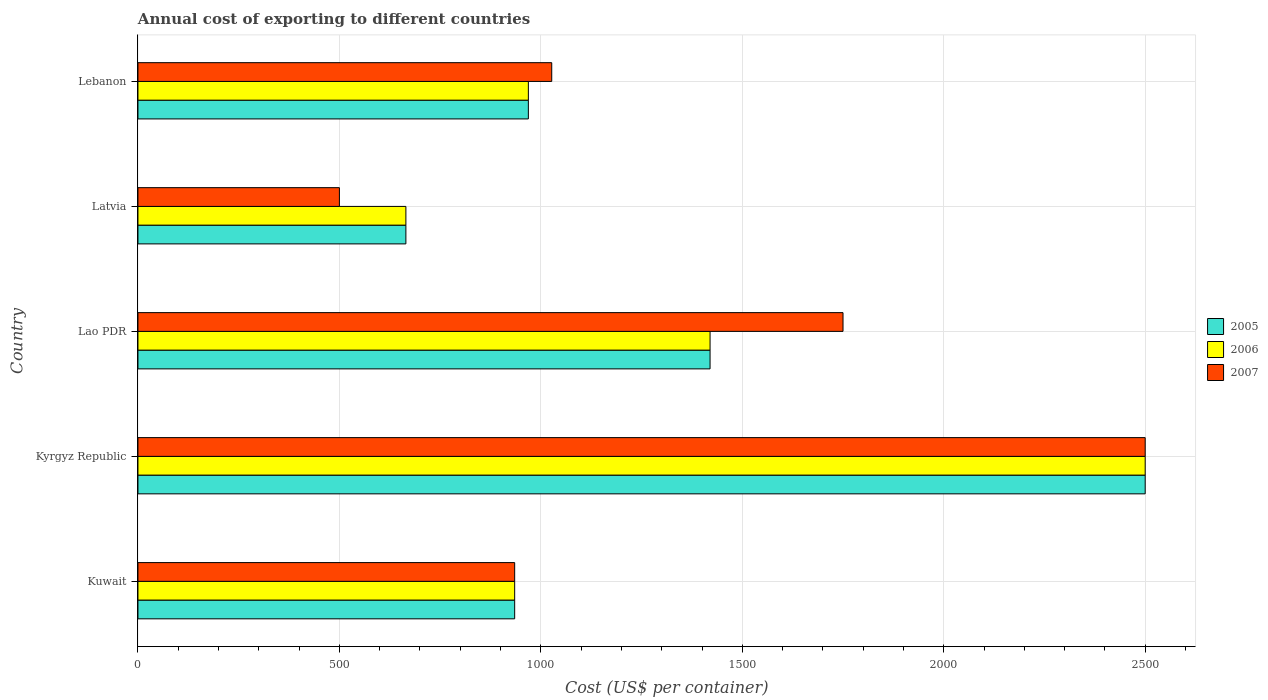How many different coloured bars are there?
Give a very brief answer. 3. How many groups of bars are there?
Your answer should be compact. 5. How many bars are there on the 3rd tick from the bottom?
Your answer should be compact. 3. What is the label of the 2nd group of bars from the top?
Your answer should be very brief. Latvia. What is the total annual cost of exporting in 2007 in Kyrgyz Republic?
Keep it short and to the point. 2500. Across all countries, what is the maximum total annual cost of exporting in 2007?
Ensure brevity in your answer.  2500. In which country was the total annual cost of exporting in 2005 maximum?
Ensure brevity in your answer.  Kyrgyz Republic. In which country was the total annual cost of exporting in 2007 minimum?
Offer a terse response. Latvia. What is the total total annual cost of exporting in 2006 in the graph?
Offer a very short reply. 6489. What is the difference between the total annual cost of exporting in 2005 in Latvia and that in Lebanon?
Offer a very short reply. -304. What is the difference between the total annual cost of exporting in 2005 in Lao PDR and the total annual cost of exporting in 2006 in Kyrgyz Republic?
Provide a succinct answer. -1080. What is the average total annual cost of exporting in 2007 per country?
Provide a short and direct response. 1342.4. What is the difference between the total annual cost of exporting in 2007 and total annual cost of exporting in 2006 in Lao PDR?
Keep it short and to the point. 330. In how many countries, is the total annual cost of exporting in 2006 greater than 400 US$?
Your response must be concise. 5. What is the ratio of the total annual cost of exporting in 2006 in Kuwait to that in Kyrgyz Republic?
Offer a very short reply. 0.37. Is the total annual cost of exporting in 2005 in Kuwait less than that in Lebanon?
Give a very brief answer. Yes. What is the difference between the highest and the second highest total annual cost of exporting in 2007?
Make the answer very short. 750. What is the difference between the highest and the lowest total annual cost of exporting in 2006?
Provide a short and direct response. 1835. Is the sum of the total annual cost of exporting in 2006 in Lao PDR and Latvia greater than the maximum total annual cost of exporting in 2007 across all countries?
Offer a terse response. No. What does the 2nd bar from the bottom in Kyrgyz Republic represents?
Your answer should be compact. 2006. Are the values on the major ticks of X-axis written in scientific E-notation?
Your answer should be compact. No. Does the graph contain any zero values?
Ensure brevity in your answer.  No. How many legend labels are there?
Your answer should be compact. 3. What is the title of the graph?
Ensure brevity in your answer.  Annual cost of exporting to different countries. What is the label or title of the X-axis?
Provide a succinct answer. Cost (US$ per container). What is the label or title of the Y-axis?
Give a very brief answer. Country. What is the Cost (US$ per container) in 2005 in Kuwait?
Provide a succinct answer. 935. What is the Cost (US$ per container) of 2006 in Kuwait?
Ensure brevity in your answer.  935. What is the Cost (US$ per container) in 2007 in Kuwait?
Offer a terse response. 935. What is the Cost (US$ per container) in 2005 in Kyrgyz Republic?
Provide a short and direct response. 2500. What is the Cost (US$ per container) in 2006 in Kyrgyz Republic?
Make the answer very short. 2500. What is the Cost (US$ per container) of 2007 in Kyrgyz Republic?
Keep it short and to the point. 2500. What is the Cost (US$ per container) in 2005 in Lao PDR?
Provide a short and direct response. 1420. What is the Cost (US$ per container) of 2006 in Lao PDR?
Your response must be concise. 1420. What is the Cost (US$ per container) in 2007 in Lao PDR?
Your response must be concise. 1750. What is the Cost (US$ per container) in 2005 in Latvia?
Ensure brevity in your answer.  665. What is the Cost (US$ per container) of 2006 in Latvia?
Give a very brief answer. 665. What is the Cost (US$ per container) in 2005 in Lebanon?
Make the answer very short. 969. What is the Cost (US$ per container) in 2006 in Lebanon?
Ensure brevity in your answer.  969. What is the Cost (US$ per container) in 2007 in Lebanon?
Provide a short and direct response. 1027. Across all countries, what is the maximum Cost (US$ per container) of 2005?
Your answer should be compact. 2500. Across all countries, what is the maximum Cost (US$ per container) of 2006?
Ensure brevity in your answer.  2500. Across all countries, what is the maximum Cost (US$ per container) in 2007?
Keep it short and to the point. 2500. Across all countries, what is the minimum Cost (US$ per container) in 2005?
Give a very brief answer. 665. Across all countries, what is the minimum Cost (US$ per container) in 2006?
Give a very brief answer. 665. What is the total Cost (US$ per container) in 2005 in the graph?
Ensure brevity in your answer.  6489. What is the total Cost (US$ per container) in 2006 in the graph?
Keep it short and to the point. 6489. What is the total Cost (US$ per container) in 2007 in the graph?
Offer a very short reply. 6712. What is the difference between the Cost (US$ per container) of 2005 in Kuwait and that in Kyrgyz Republic?
Give a very brief answer. -1565. What is the difference between the Cost (US$ per container) of 2006 in Kuwait and that in Kyrgyz Republic?
Offer a terse response. -1565. What is the difference between the Cost (US$ per container) of 2007 in Kuwait and that in Kyrgyz Republic?
Offer a terse response. -1565. What is the difference between the Cost (US$ per container) in 2005 in Kuwait and that in Lao PDR?
Your answer should be very brief. -485. What is the difference between the Cost (US$ per container) of 2006 in Kuwait and that in Lao PDR?
Your answer should be very brief. -485. What is the difference between the Cost (US$ per container) of 2007 in Kuwait and that in Lao PDR?
Keep it short and to the point. -815. What is the difference between the Cost (US$ per container) of 2005 in Kuwait and that in Latvia?
Keep it short and to the point. 270. What is the difference between the Cost (US$ per container) in 2006 in Kuwait and that in Latvia?
Offer a terse response. 270. What is the difference between the Cost (US$ per container) in 2007 in Kuwait and that in Latvia?
Provide a short and direct response. 435. What is the difference between the Cost (US$ per container) in 2005 in Kuwait and that in Lebanon?
Give a very brief answer. -34. What is the difference between the Cost (US$ per container) of 2006 in Kuwait and that in Lebanon?
Ensure brevity in your answer.  -34. What is the difference between the Cost (US$ per container) of 2007 in Kuwait and that in Lebanon?
Your response must be concise. -92. What is the difference between the Cost (US$ per container) of 2005 in Kyrgyz Republic and that in Lao PDR?
Your answer should be compact. 1080. What is the difference between the Cost (US$ per container) in 2006 in Kyrgyz Republic and that in Lao PDR?
Offer a terse response. 1080. What is the difference between the Cost (US$ per container) in 2007 in Kyrgyz Republic and that in Lao PDR?
Provide a succinct answer. 750. What is the difference between the Cost (US$ per container) in 2005 in Kyrgyz Republic and that in Latvia?
Your answer should be very brief. 1835. What is the difference between the Cost (US$ per container) in 2006 in Kyrgyz Republic and that in Latvia?
Make the answer very short. 1835. What is the difference between the Cost (US$ per container) of 2007 in Kyrgyz Republic and that in Latvia?
Provide a succinct answer. 2000. What is the difference between the Cost (US$ per container) of 2005 in Kyrgyz Republic and that in Lebanon?
Your response must be concise. 1531. What is the difference between the Cost (US$ per container) of 2006 in Kyrgyz Republic and that in Lebanon?
Your answer should be very brief. 1531. What is the difference between the Cost (US$ per container) in 2007 in Kyrgyz Republic and that in Lebanon?
Provide a succinct answer. 1473. What is the difference between the Cost (US$ per container) of 2005 in Lao PDR and that in Latvia?
Provide a short and direct response. 755. What is the difference between the Cost (US$ per container) of 2006 in Lao PDR and that in Latvia?
Ensure brevity in your answer.  755. What is the difference between the Cost (US$ per container) of 2007 in Lao PDR and that in Latvia?
Your answer should be compact. 1250. What is the difference between the Cost (US$ per container) of 2005 in Lao PDR and that in Lebanon?
Make the answer very short. 451. What is the difference between the Cost (US$ per container) of 2006 in Lao PDR and that in Lebanon?
Offer a very short reply. 451. What is the difference between the Cost (US$ per container) in 2007 in Lao PDR and that in Lebanon?
Give a very brief answer. 723. What is the difference between the Cost (US$ per container) of 2005 in Latvia and that in Lebanon?
Give a very brief answer. -304. What is the difference between the Cost (US$ per container) of 2006 in Latvia and that in Lebanon?
Your response must be concise. -304. What is the difference between the Cost (US$ per container) in 2007 in Latvia and that in Lebanon?
Provide a short and direct response. -527. What is the difference between the Cost (US$ per container) in 2005 in Kuwait and the Cost (US$ per container) in 2006 in Kyrgyz Republic?
Ensure brevity in your answer.  -1565. What is the difference between the Cost (US$ per container) of 2005 in Kuwait and the Cost (US$ per container) of 2007 in Kyrgyz Republic?
Your response must be concise. -1565. What is the difference between the Cost (US$ per container) of 2006 in Kuwait and the Cost (US$ per container) of 2007 in Kyrgyz Republic?
Provide a short and direct response. -1565. What is the difference between the Cost (US$ per container) of 2005 in Kuwait and the Cost (US$ per container) of 2006 in Lao PDR?
Your answer should be very brief. -485. What is the difference between the Cost (US$ per container) of 2005 in Kuwait and the Cost (US$ per container) of 2007 in Lao PDR?
Your answer should be compact. -815. What is the difference between the Cost (US$ per container) in 2006 in Kuwait and the Cost (US$ per container) in 2007 in Lao PDR?
Ensure brevity in your answer.  -815. What is the difference between the Cost (US$ per container) in 2005 in Kuwait and the Cost (US$ per container) in 2006 in Latvia?
Ensure brevity in your answer.  270. What is the difference between the Cost (US$ per container) in 2005 in Kuwait and the Cost (US$ per container) in 2007 in Latvia?
Ensure brevity in your answer.  435. What is the difference between the Cost (US$ per container) of 2006 in Kuwait and the Cost (US$ per container) of 2007 in Latvia?
Your answer should be compact. 435. What is the difference between the Cost (US$ per container) of 2005 in Kuwait and the Cost (US$ per container) of 2006 in Lebanon?
Keep it short and to the point. -34. What is the difference between the Cost (US$ per container) of 2005 in Kuwait and the Cost (US$ per container) of 2007 in Lebanon?
Offer a terse response. -92. What is the difference between the Cost (US$ per container) of 2006 in Kuwait and the Cost (US$ per container) of 2007 in Lebanon?
Provide a short and direct response. -92. What is the difference between the Cost (US$ per container) of 2005 in Kyrgyz Republic and the Cost (US$ per container) of 2006 in Lao PDR?
Provide a succinct answer. 1080. What is the difference between the Cost (US$ per container) in 2005 in Kyrgyz Republic and the Cost (US$ per container) in 2007 in Lao PDR?
Keep it short and to the point. 750. What is the difference between the Cost (US$ per container) of 2006 in Kyrgyz Republic and the Cost (US$ per container) of 2007 in Lao PDR?
Ensure brevity in your answer.  750. What is the difference between the Cost (US$ per container) of 2005 in Kyrgyz Republic and the Cost (US$ per container) of 2006 in Latvia?
Your response must be concise. 1835. What is the difference between the Cost (US$ per container) in 2006 in Kyrgyz Republic and the Cost (US$ per container) in 2007 in Latvia?
Ensure brevity in your answer.  2000. What is the difference between the Cost (US$ per container) in 2005 in Kyrgyz Republic and the Cost (US$ per container) in 2006 in Lebanon?
Your response must be concise. 1531. What is the difference between the Cost (US$ per container) in 2005 in Kyrgyz Republic and the Cost (US$ per container) in 2007 in Lebanon?
Offer a terse response. 1473. What is the difference between the Cost (US$ per container) in 2006 in Kyrgyz Republic and the Cost (US$ per container) in 2007 in Lebanon?
Ensure brevity in your answer.  1473. What is the difference between the Cost (US$ per container) in 2005 in Lao PDR and the Cost (US$ per container) in 2006 in Latvia?
Provide a short and direct response. 755. What is the difference between the Cost (US$ per container) in 2005 in Lao PDR and the Cost (US$ per container) in 2007 in Latvia?
Your answer should be compact. 920. What is the difference between the Cost (US$ per container) of 2006 in Lao PDR and the Cost (US$ per container) of 2007 in Latvia?
Provide a succinct answer. 920. What is the difference between the Cost (US$ per container) in 2005 in Lao PDR and the Cost (US$ per container) in 2006 in Lebanon?
Provide a short and direct response. 451. What is the difference between the Cost (US$ per container) in 2005 in Lao PDR and the Cost (US$ per container) in 2007 in Lebanon?
Your answer should be very brief. 393. What is the difference between the Cost (US$ per container) in 2006 in Lao PDR and the Cost (US$ per container) in 2007 in Lebanon?
Make the answer very short. 393. What is the difference between the Cost (US$ per container) in 2005 in Latvia and the Cost (US$ per container) in 2006 in Lebanon?
Your answer should be very brief. -304. What is the difference between the Cost (US$ per container) in 2005 in Latvia and the Cost (US$ per container) in 2007 in Lebanon?
Keep it short and to the point. -362. What is the difference between the Cost (US$ per container) in 2006 in Latvia and the Cost (US$ per container) in 2007 in Lebanon?
Your answer should be very brief. -362. What is the average Cost (US$ per container) of 2005 per country?
Make the answer very short. 1297.8. What is the average Cost (US$ per container) in 2006 per country?
Your answer should be compact. 1297.8. What is the average Cost (US$ per container) of 2007 per country?
Offer a very short reply. 1342.4. What is the difference between the Cost (US$ per container) in 2005 and Cost (US$ per container) in 2006 in Kuwait?
Your answer should be very brief. 0. What is the difference between the Cost (US$ per container) of 2005 and Cost (US$ per container) of 2007 in Kuwait?
Provide a succinct answer. 0. What is the difference between the Cost (US$ per container) of 2005 and Cost (US$ per container) of 2006 in Kyrgyz Republic?
Your answer should be very brief. 0. What is the difference between the Cost (US$ per container) in 2005 and Cost (US$ per container) in 2007 in Kyrgyz Republic?
Offer a very short reply. 0. What is the difference between the Cost (US$ per container) in 2005 and Cost (US$ per container) in 2007 in Lao PDR?
Provide a short and direct response. -330. What is the difference between the Cost (US$ per container) in 2006 and Cost (US$ per container) in 2007 in Lao PDR?
Ensure brevity in your answer.  -330. What is the difference between the Cost (US$ per container) of 2005 and Cost (US$ per container) of 2006 in Latvia?
Make the answer very short. 0. What is the difference between the Cost (US$ per container) of 2005 and Cost (US$ per container) of 2007 in Latvia?
Provide a short and direct response. 165. What is the difference between the Cost (US$ per container) of 2006 and Cost (US$ per container) of 2007 in Latvia?
Offer a very short reply. 165. What is the difference between the Cost (US$ per container) in 2005 and Cost (US$ per container) in 2007 in Lebanon?
Your response must be concise. -58. What is the difference between the Cost (US$ per container) in 2006 and Cost (US$ per container) in 2007 in Lebanon?
Offer a very short reply. -58. What is the ratio of the Cost (US$ per container) of 2005 in Kuwait to that in Kyrgyz Republic?
Your answer should be compact. 0.37. What is the ratio of the Cost (US$ per container) of 2006 in Kuwait to that in Kyrgyz Republic?
Provide a short and direct response. 0.37. What is the ratio of the Cost (US$ per container) of 2007 in Kuwait to that in Kyrgyz Republic?
Your response must be concise. 0.37. What is the ratio of the Cost (US$ per container) in 2005 in Kuwait to that in Lao PDR?
Give a very brief answer. 0.66. What is the ratio of the Cost (US$ per container) in 2006 in Kuwait to that in Lao PDR?
Provide a short and direct response. 0.66. What is the ratio of the Cost (US$ per container) of 2007 in Kuwait to that in Lao PDR?
Your answer should be compact. 0.53. What is the ratio of the Cost (US$ per container) of 2005 in Kuwait to that in Latvia?
Offer a terse response. 1.41. What is the ratio of the Cost (US$ per container) in 2006 in Kuwait to that in Latvia?
Your answer should be very brief. 1.41. What is the ratio of the Cost (US$ per container) of 2007 in Kuwait to that in Latvia?
Make the answer very short. 1.87. What is the ratio of the Cost (US$ per container) in 2005 in Kuwait to that in Lebanon?
Give a very brief answer. 0.96. What is the ratio of the Cost (US$ per container) in 2006 in Kuwait to that in Lebanon?
Make the answer very short. 0.96. What is the ratio of the Cost (US$ per container) of 2007 in Kuwait to that in Lebanon?
Give a very brief answer. 0.91. What is the ratio of the Cost (US$ per container) in 2005 in Kyrgyz Republic to that in Lao PDR?
Offer a terse response. 1.76. What is the ratio of the Cost (US$ per container) of 2006 in Kyrgyz Republic to that in Lao PDR?
Your answer should be compact. 1.76. What is the ratio of the Cost (US$ per container) in 2007 in Kyrgyz Republic to that in Lao PDR?
Keep it short and to the point. 1.43. What is the ratio of the Cost (US$ per container) of 2005 in Kyrgyz Republic to that in Latvia?
Provide a succinct answer. 3.76. What is the ratio of the Cost (US$ per container) of 2006 in Kyrgyz Republic to that in Latvia?
Your response must be concise. 3.76. What is the ratio of the Cost (US$ per container) of 2007 in Kyrgyz Republic to that in Latvia?
Ensure brevity in your answer.  5. What is the ratio of the Cost (US$ per container) of 2005 in Kyrgyz Republic to that in Lebanon?
Give a very brief answer. 2.58. What is the ratio of the Cost (US$ per container) of 2006 in Kyrgyz Republic to that in Lebanon?
Your answer should be very brief. 2.58. What is the ratio of the Cost (US$ per container) of 2007 in Kyrgyz Republic to that in Lebanon?
Offer a very short reply. 2.43. What is the ratio of the Cost (US$ per container) of 2005 in Lao PDR to that in Latvia?
Keep it short and to the point. 2.14. What is the ratio of the Cost (US$ per container) of 2006 in Lao PDR to that in Latvia?
Offer a very short reply. 2.14. What is the ratio of the Cost (US$ per container) of 2007 in Lao PDR to that in Latvia?
Make the answer very short. 3.5. What is the ratio of the Cost (US$ per container) in 2005 in Lao PDR to that in Lebanon?
Provide a short and direct response. 1.47. What is the ratio of the Cost (US$ per container) of 2006 in Lao PDR to that in Lebanon?
Provide a succinct answer. 1.47. What is the ratio of the Cost (US$ per container) of 2007 in Lao PDR to that in Lebanon?
Your answer should be compact. 1.7. What is the ratio of the Cost (US$ per container) in 2005 in Latvia to that in Lebanon?
Your answer should be very brief. 0.69. What is the ratio of the Cost (US$ per container) of 2006 in Latvia to that in Lebanon?
Give a very brief answer. 0.69. What is the ratio of the Cost (US$ per container) of 2007 in Latvia to that in Lebanon?
Your answer should be very brief. 0.49. What is the difference between the highest and the second highest Cost (US$ per container) in 2005?
Provide a short and direct response. 1080. What is the difference between the highest and the second highest Cost (US$ per container) in 2006?
Keep it short and to the point. 1080. What is the difference between the highest and the second highest Cost (US$ per container) in 2007?
Keep it short and to the point. 750. What is the difference between the highest and the lowest Cost (US$ per container) of 2005?
Make the answer very short. 1835. What is the difference between the highest and the lowest Cost (US$ per container) of 2006?
Ensure brevity in your answer.  1835. What is the difference between the highest and the lowest Cost (US$ per container) of 2007?
Keep it short and to the point. 2000. 